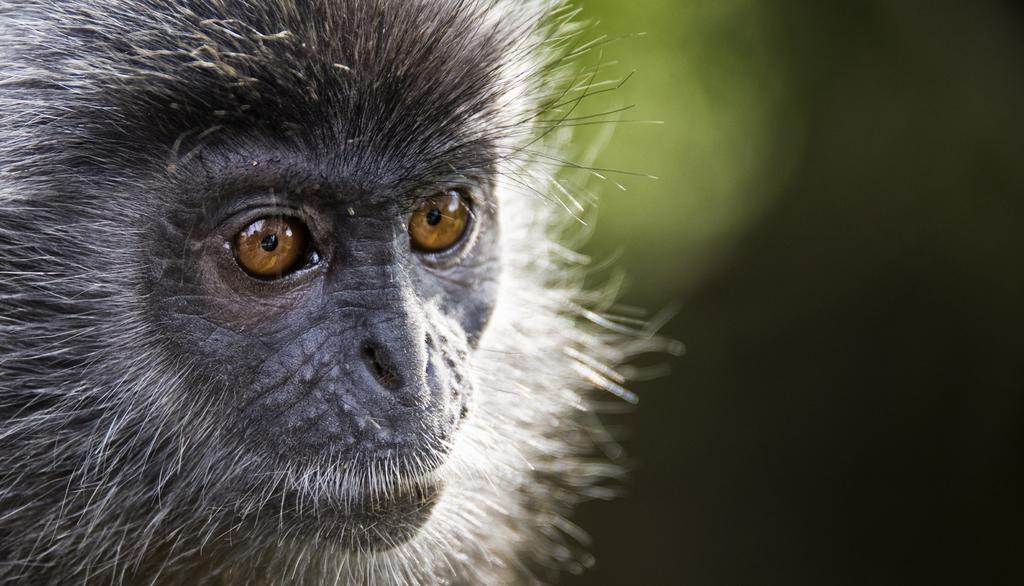What type of subject is present in the image? There is an animal in the image. Can you describe the background of the image? The background of the image is blurred. What type of gun is being used by the animal in the image? There is no gun present in the image; it features an animal with a blurred background. 